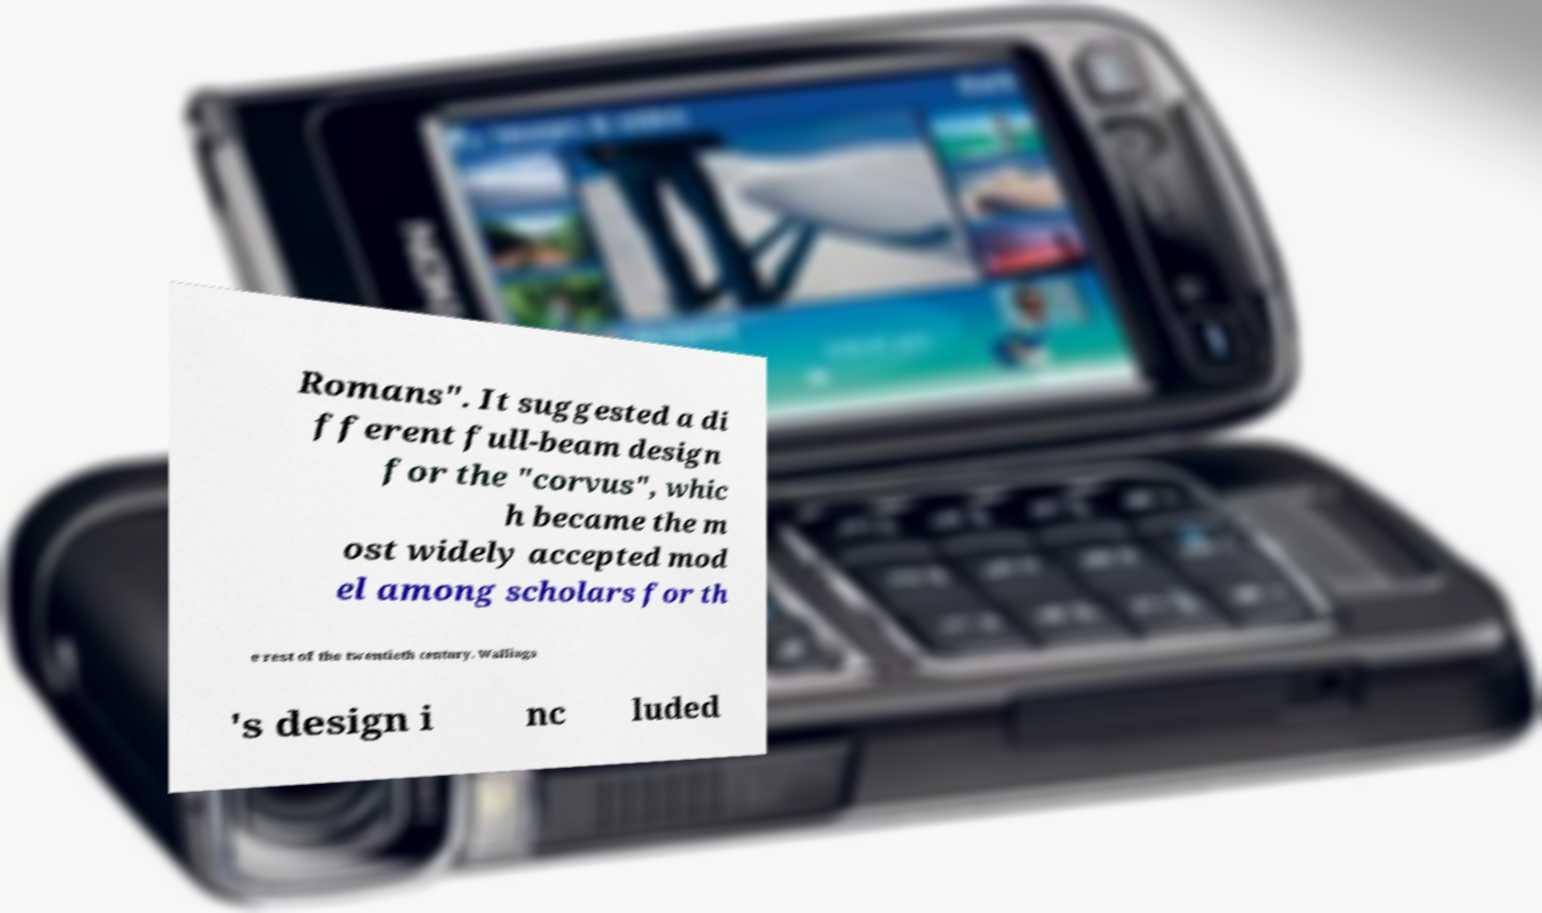Please identify and transcribe the text found in this image. Romans". It suggested a di fferent full-beam design for the "corvus", whic h became the m ost widely accepted mod el among scholars for th e rest of the twentieth century. Wallinga 's design i nc luded 